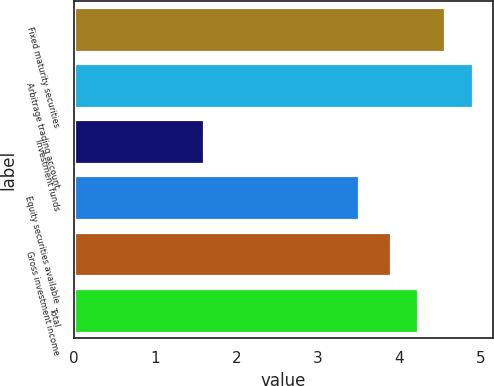Convert chart to OTSL. <chart><loc_0><loc_0><loc_500><loc_500><bar_chart><fcel>Fixed maturity securities<fcel>Arbitrage trading account<fcel>Investment funds<fcel>Equity securities available<fcel>Gross investment income<fcel>Total<nl><fcel>4.56<fcel>4.9<fcel>1.6<fcel>3.5<fcel>3.9<fcel>4.23<nl></chart> 